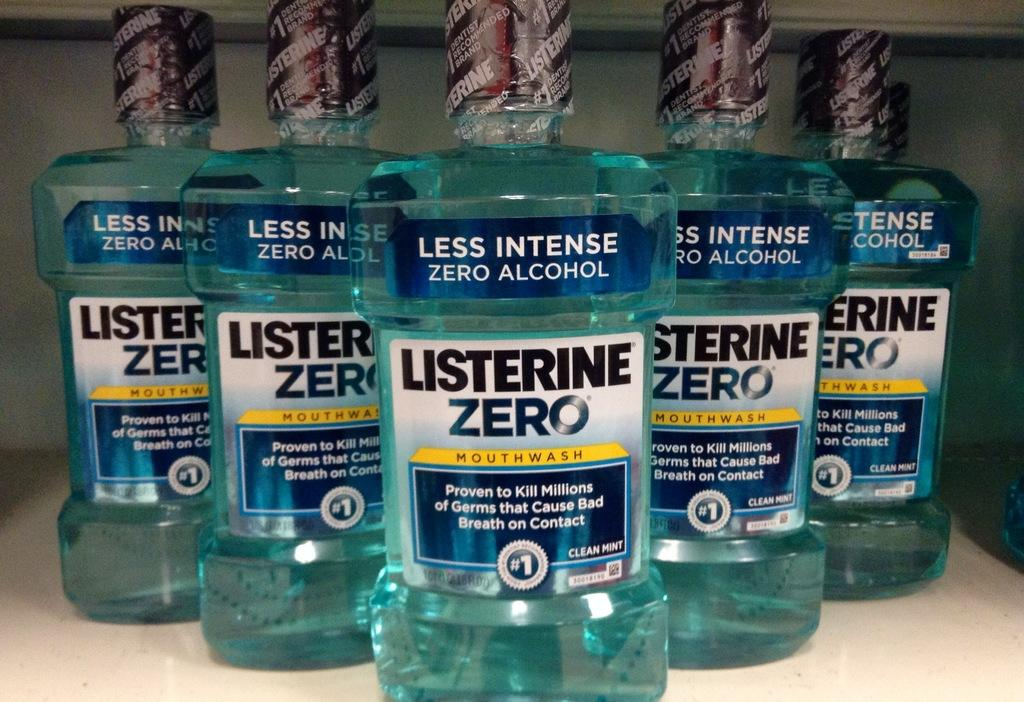What brand of germs cleaning bottles are in the image? The germs cleaning bottles in the image are from the Listerine brand. Where are the bottles located in the image? The bottles are on a table in the image. What type of polish is being applied to the bottles in the image? There is no polish being applied to the bottles in the image; they are germs cleaning bottles. 